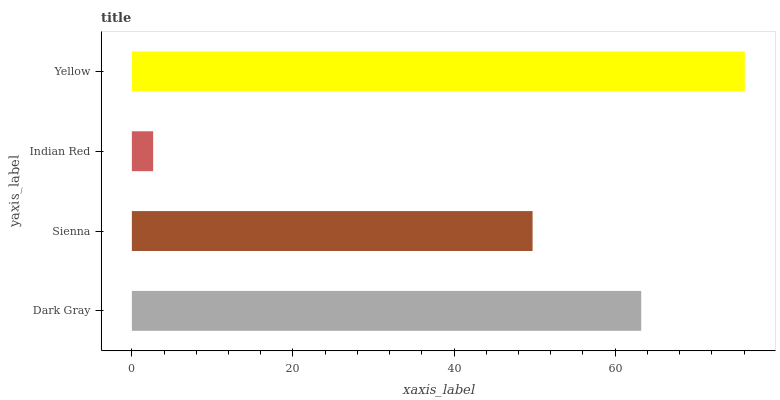Is Indian Red the minimum?
Answer yes or no. Yes. Is Yellow the maximum?
Answer yes or no. Yes. Is Sienna the minimum?
Answer yes or no. No. Is Sienna the maximum?
Answer yes or no. No. Is Dark Gray greater than Sienna?
Answer yes or no. Yes. Is Sienna less than Dark Gray?
Answer yes or no. Yes. Is Sienna greater than Dark Gray?
Answer yes or no. No. Is Dark Gray less than Sienna?
Answer yes or no. No. Is Dark Gray the high median?
Answer yes or no. Yes. Is Sienna the low median?
Answer yes or no. Yes. Is Yellow the high median?
Answer yes or no. No. Is Indian Red the low median?
Answer yes or no. No. 